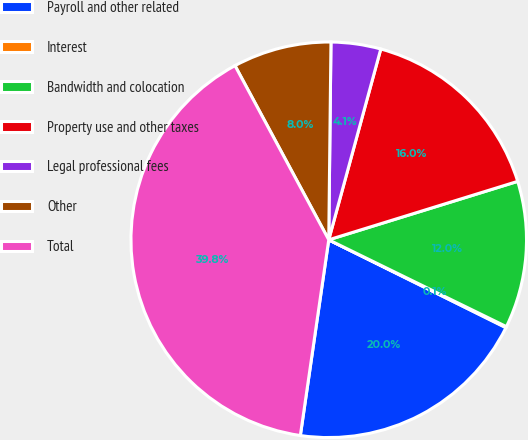Convert chart. <chart><loc_0><loc_0><loc_500><loc_500><pie_chart><fcel>Payroll and other related<fcel>Interest<fcel>Bandwidth and colocation<fcel>Property use and other taxes<fcel>Legal professional fees<fcel>Other<fcel>Total<nl><fcel>19.97%<fcel>0.09%<fcel>12.01%<fcel>15.99%<fcel>4.06%<fcel>8.04%<fcel>39.85%<nl></chart> 